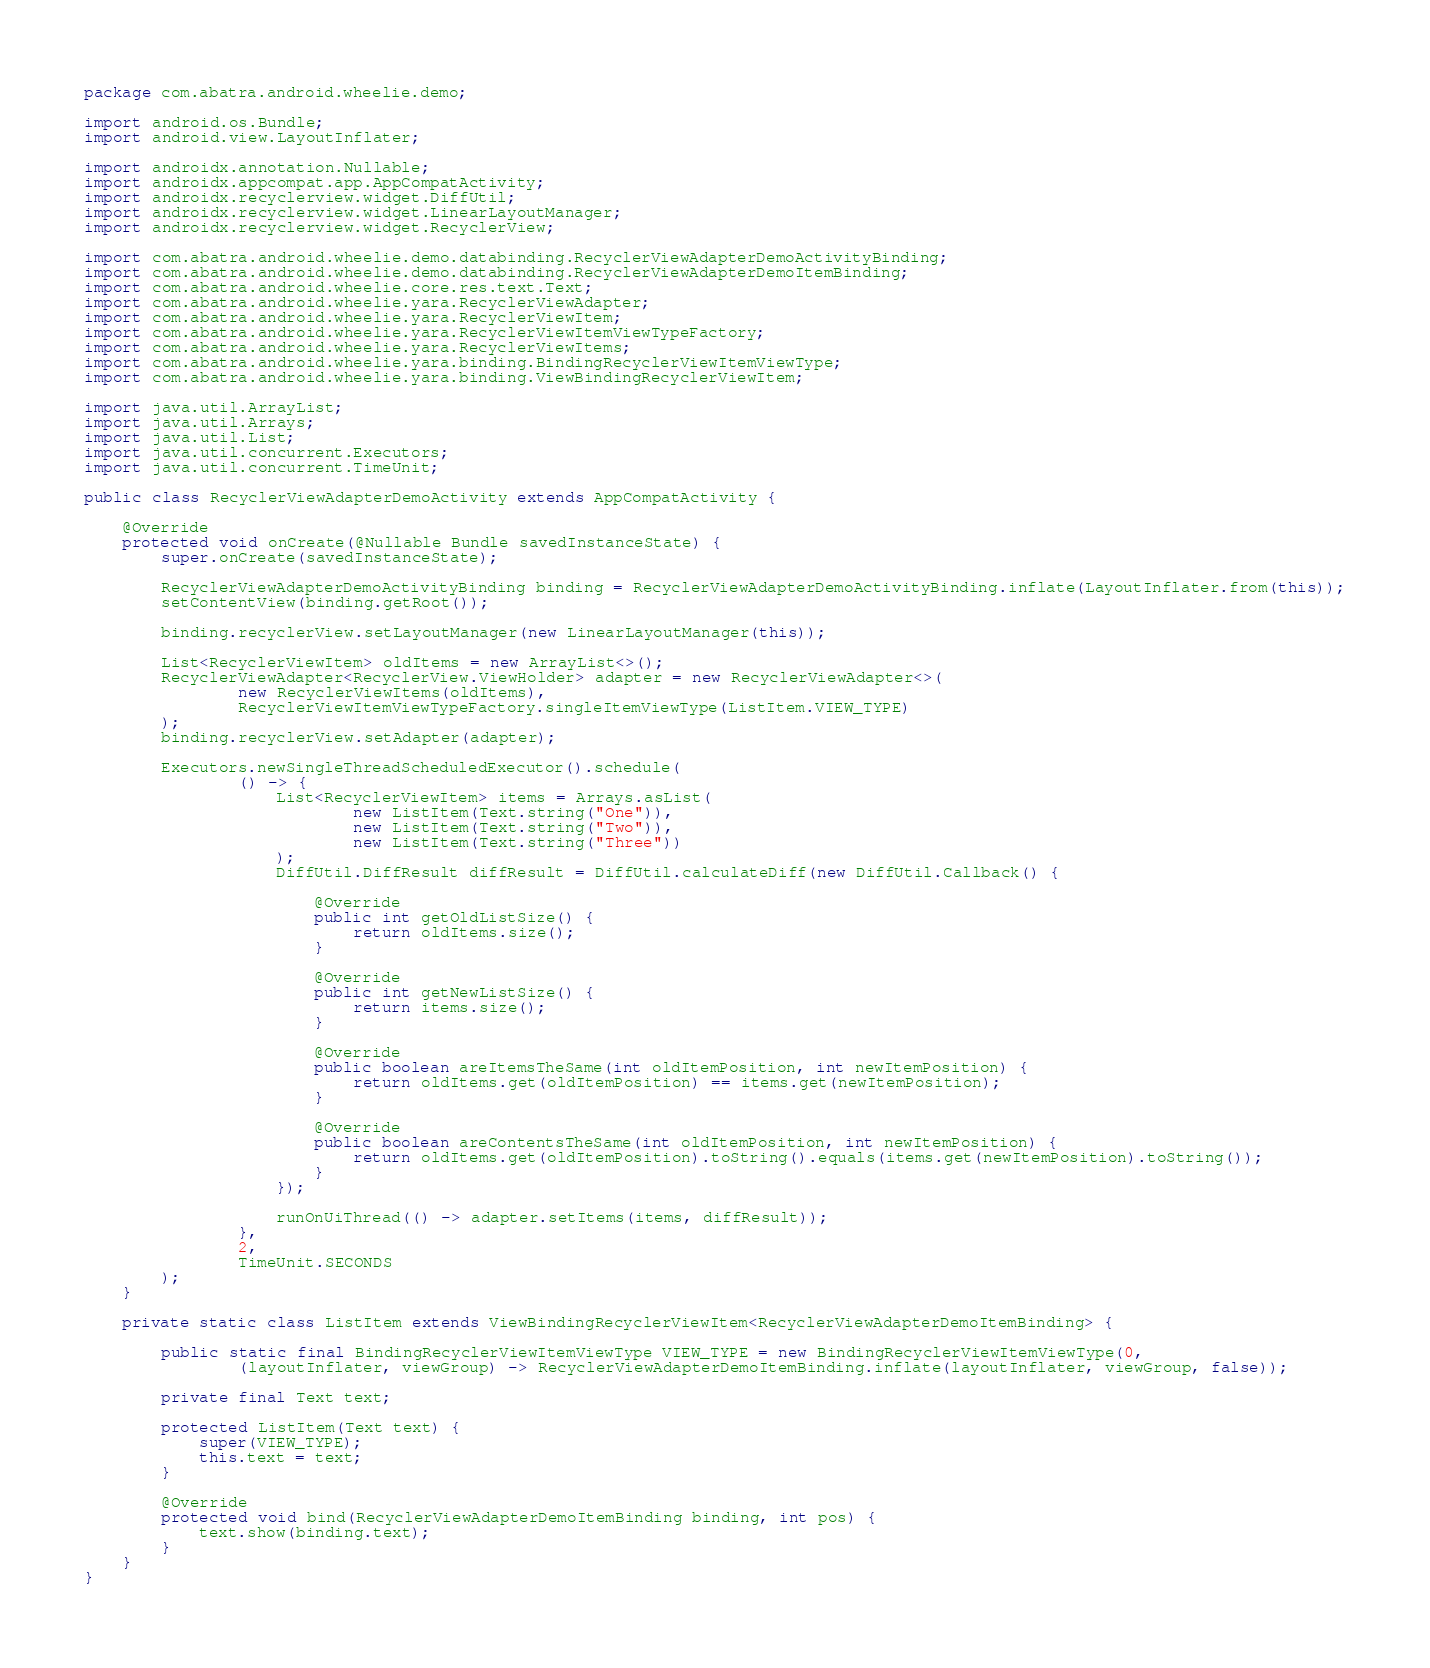Convert code to text. <code><loc_0><loc_0><loc_500><loc_500><_Java_>package com.abatra.android.wheelie.demo;

import android.os.Bundle;
import android.view.LayoutInflater;

import androidx.annotation.Nullable;
import androidx.appcompat.app.AppCompatActivity;
import androidx.recyclerview.widget.DiffUtil;
import androidx.recyclerview.widget.LinearLayoutManager;
import androidx.recyclerview.widget.RecyclerView;

import com.abatra.android.wheelie.demo.databinding.RecyclerViewAdapterDemoActivityBinding;
import com.abatra.android.wheelie.demo.databinding.RecyclerViewAdapterDemoItemBinding;
import com.abatra.android.wheelie.core.res.text.Text;
import com.abatra.android.wheelie.yara.RecyclerViewAdapter;
import com.abatra.android.wheelie.yara.RecyclerViewItem;
import com.abatra.android.wheelie.yara.RecyclerViewItemViewTypeFactory;
import com.abatra.android.wheelie.yara.RecyclerViewItems;
import com.abatra.android.wheelie.yara.binding.BindingRecyclerViewItemViewType;
import com.abatra.android.wheelie.yara.binding.ViewBindingRecyclerViewItem;

import java.util.ArrayList;
import java.util.Arrays;
import java.util.List;
import java.util.concurrent.Executors;
import java.util.concurrent.TimeUnit;

public class RecyclerViewAdapterDemoActivity extends AppCompatActivity {

    @Override
    protected void onCreate(@Nullable Bundle savedInstanceState) {
        super.onCreate(savedInstanceState);

        RecyclerViewAdapterDemoActivityBinding binding = RecyclerViewAdapterDemoActivityBinding.inflate(LayoutInflater.from(this));
        setContentView(binding.getRoot());

        binding.recyclerView.setLayoutManager(new LinearLayoutManager(this));

        List<RecyclerViewItem> oldItems = new ArrayList<>();
        RecyclerViewAdapter<RecyclerView.ViewHolder> adapter = new RecyclerViewAdapter<>(
                new RecyclerViewItems(oldItems),
                RecyclerViewItemViewTypeFactory.singleItemViewType(ListItem.VIEW_TYPE)
        );
        binding.recyclerView.setAdapter(adapter);

        Executors.newSingleThreadScheduledExecutor().schedule(
                () -> {
                    List<RecyclerViewItem> items = Arrays.asList(
                            new ListItem(Text.string("One")),
                            new ListItem(Text.string("Two")),
                            new ListItem(Text.string("Three"))
                    );
                    DiffUtil.DiffResult diffResult = DiffUtil.calculateDiff(new DiffUtil.Callback() {

                        @Override
                        public int getOldListSize() {
                            return oldItems.size();
                        }

                        @Override
                        public int getNewListSize() {
                            return items.size();
                        }

                        @Override
                        public boolean areItemsTheSame(int oldItemPosition, int newItemPosition) {
                            return oldItems.get(oldItemPosition) == items.get(newItemPosition);
                        }

                        @Override
                        public boolean areContentsTheSame(int oldItemPosition, int newItemPosition) {
                            return oldItems.get(oldItemPosition).toString().equals(items.get(newItemPosition).toString());
                        }
                    });

                    runOnUiThread(() -> adapter.setItems(items, diffResult));
                },
                2,
                TimeUnit.SECONDS
        );
    }

    private static class ListItem extends ViewBindingRecyclerViewItem<RecyclerViewAdapterDemoItemBinding> {

        public static final BindingRecyclerViewItemViewType VIEW_TYPE = new BindingRecyclerViewItemViewType(0,
                (layoutInflater, viewGroup) -> RecyclerViewAdapterDemoItemBinding.inflate(layoutInflater, viewGroup, false));

        private final Text text;

        protected ListItem(Text text) {
            super(VIEW_TYPE);
            this.text = text;
        }

        @Override
        protected void bind(RecyclerViewAdapterDemoItemBinding binding, int pos) {
            text.show(binding.text);
        }
    }
}
</code> 